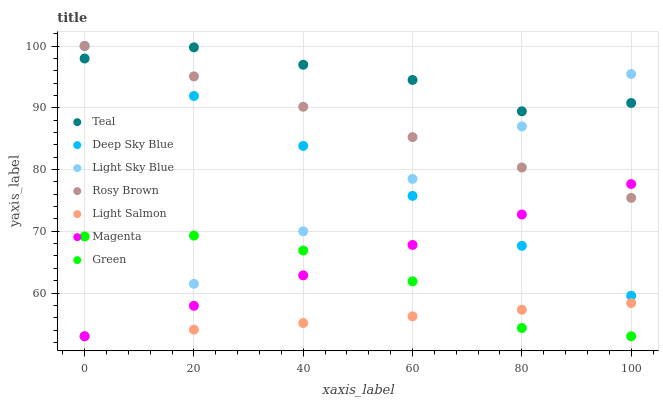Does Light Salmon have the minimum area under the curve?
Answer yes or no. Yes. Does Teal have the maximum area under the curve?
Answer yes or no. Yes. Does Rosy Brown have the minimum area under the curve?
Answer yes or no. No. Does Rosy Brown have the maximum area under the curve?
Answer yes or no. No. Is Light Salmon the smoothest?
Answer yes or no. Yes. Is Teal the roughest?
Answer yes or no. Yes. Is Rosy Brown the smoothest?
Answer yes or no. No. Is Rosy Brown the roughest?
Answer yes or no. No. Does Light Salmon have the lowest value?
Answer yes or no. Yes. Does Rosy Brown have the lowest value?
Answer yes or no. No. Does Deep Sky Blue have the highest value?
Answer yes or no. Yes. Does Teal have the highest value?
Answer yes or no. No. Is Light Salmon less than Teal?
Answer yes or no. Yes. Is Teal greater than Light Salmon?
Answer yes or no. Yes. Does Deep Sky Blue intersect Light Sky Blue?
Answer yes or no. Yes. Is Deep Sky Blue less than Light Sky Blue?
Answer yes or no. No. Is Deep Sky Blue greater than Light Sky Blue?
Answer yes or no. No. Does Light Salmon intersect Teal?
Answer yes or no. No. 